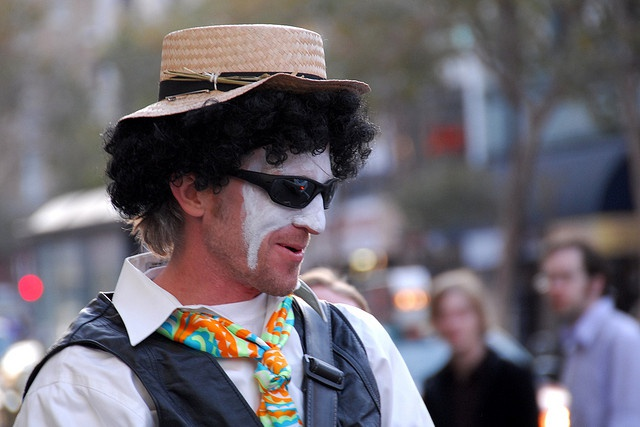Describe the objects in this image and their specific colors. I can see people in gray, black, lavender, and darkgray tones, bus in gray, darkgray, and lightgray tones, people in gray and darkgray tones, people in gray, black, and darkgray tones, and tie in gray, red, lightgreen, lightgray, and orange tones in this image. 